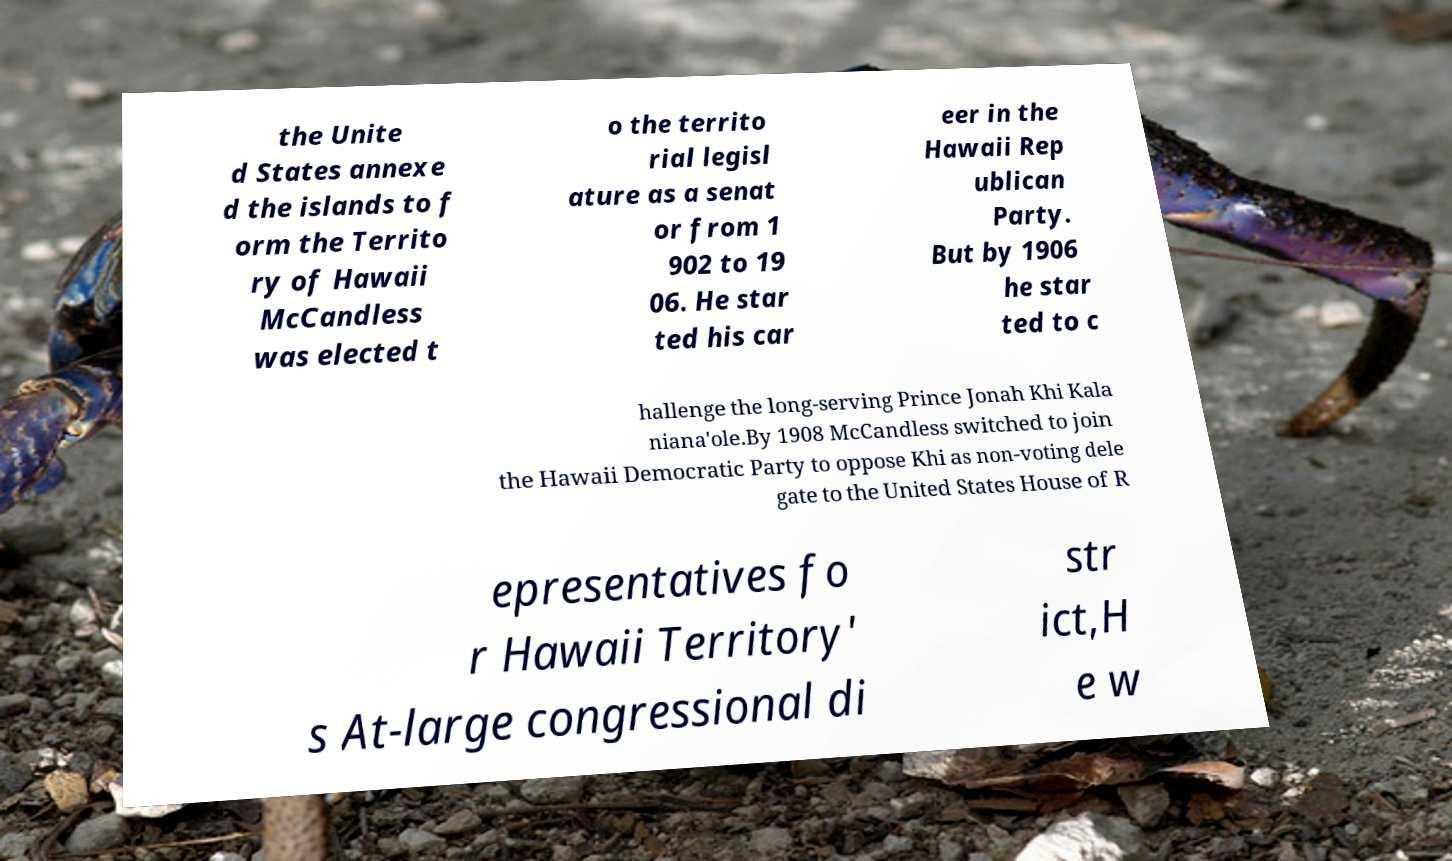For documentation purposes, I need the text within this image transcribed. Could you provide that? the Unite d States annexe d the islands to f orm the Territo ry of Hawaii McCandless was elected t o the territo rial legisl ature as a senat or from 1 902 to 19 06. He star ted his car eer in the Hawaii Rep ublican Party. But by 1906 he star ted to c hallenge the long-serving Prince Jonah Khi Kala niana'ole.By 1908 McCandless switched to join the Hawaii Democratic Party to oppose Khi as non-voting dele gate to the United States House of R epresentatives fo r Hawaii Territory' s At-large congressional di str ict,H e w 